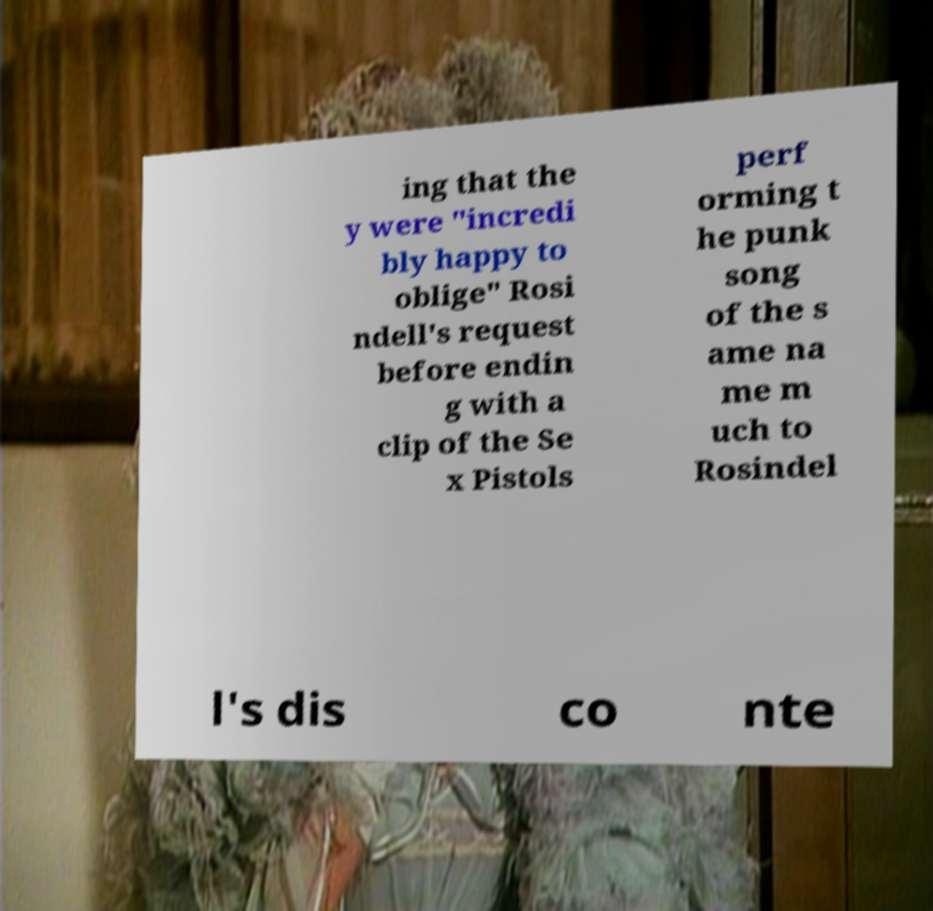Can you accurately transcribe the text from the provided image for me? ing that the y were "incredi bly happy to oblige" Rosi ndell's request before endin g with a clip of the Se x Pistols perf orming t he punk song of the s ame na me m uch to Rosindel l's dis co nte 